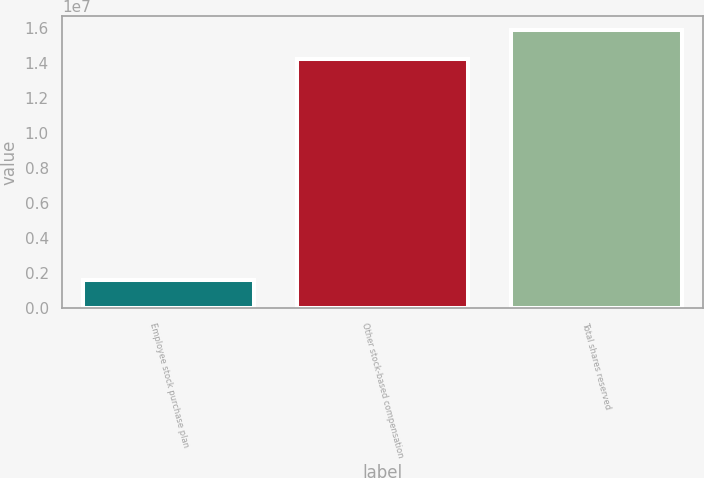<chart> <loc_0><loc_0><loc_500><loc_500><bar_chart><fcel>Employee stock purchase plan<fcel>Other stock-based compensation<fcel>Total shares reserved<nl><fcel>1.60622e+06<fcel>1.42779e+07<fcel>1.58841e+07<nl></chart> 